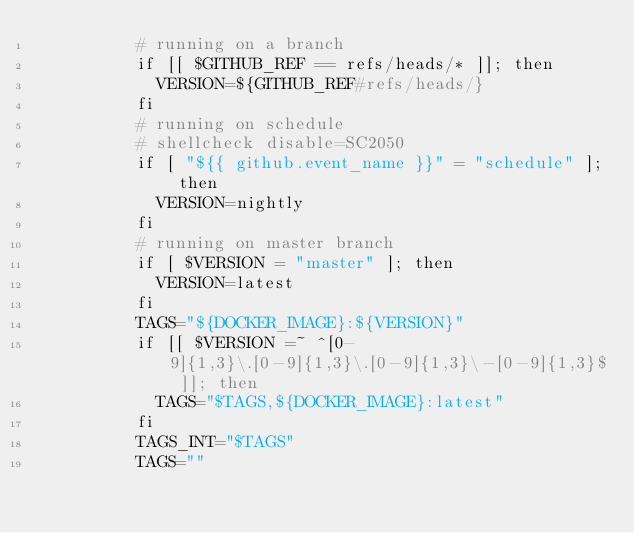Convert code to text. <code><loc_0><loc_0><loc_500><loc_500><_YAML_>          # running on a branch
          if [[ $GITHUB_REF == refs/heads/* ]]; then
            VERSION=${GITHUB_REF#refs/heads/}
          fi
          # running on schedule
          # shellcheck disable=SC2050
          if [ "${{ github.event_name }}" = "schedule" ]; then
            VERSION=nightly
          fi
          # running on master branch
          if [ $VERSION = "master" ]; then
            VERSION=latest
          fi
          TAGS="${DOCKER_IMAGE}:${VERSION}"
          if [[ $VERSION =~ ^[0-9]{1,3}\.[0-9]{1,3}\.[0-9]{1,3}\-[0-9]{1,3}$ ]]; then
            TAGS="$TAGS,${DOCKER_IMAGE}:latest"
          fi
          TAGS_INT="$TAGS"
          TAGS=""</code> 